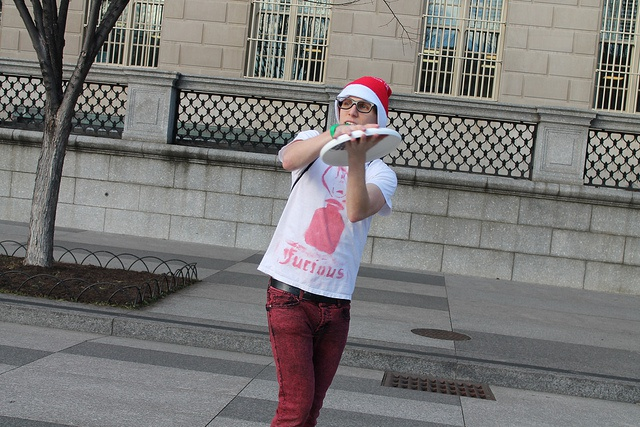Describe the objects in this image and their specific colors. I can see people in black, lavender, maroon, and darkgray tones and frisbee in black, gray, and lightgray tones in this image. 